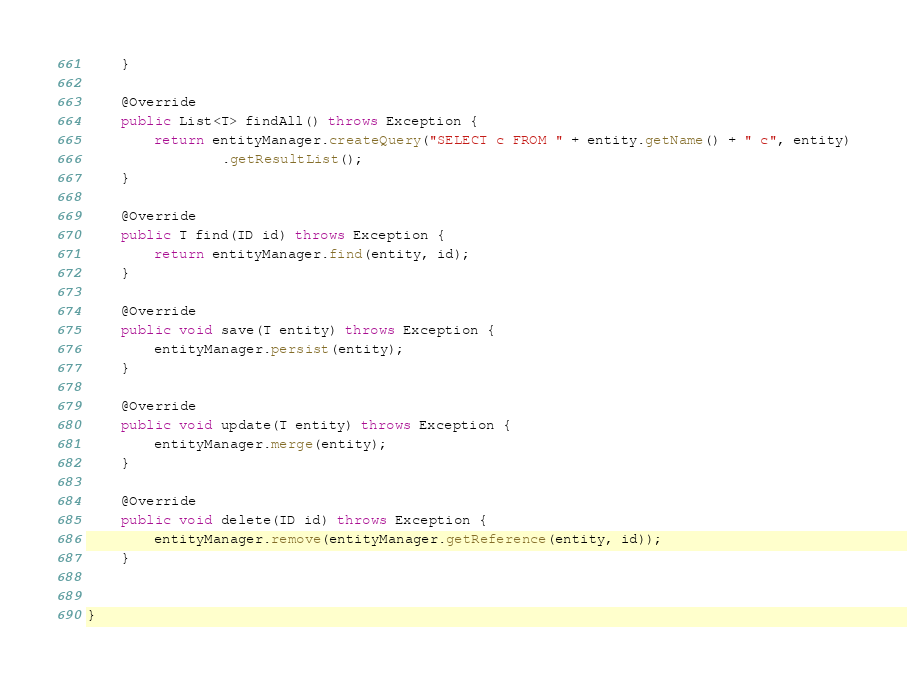<code> <loc_0><loc_0><loc_500><loc_500><_Java_>    }

    @Override
    public List<T> findAll() throws Exception {
        return entityManager.createQuery("SELECT c FROM " + entity.getName() + " c", entity)
                .getResultList();
    }

    @Override
    public T find(ID id) throws Exception {
        return entityManager.find(entity, id);
    }

    @Override
    public void save(T entity) throws Exception {
        entityManager.persist(entity);
    }

    @Override
    public void update(T entity) throws Exception {
        entityManager.merge(entity);
    }

    @Override
    public void delete(ID id) throws Exception {
        entityManager.remove(entityManager.getReference(entity, id));
    }


}
</code> 